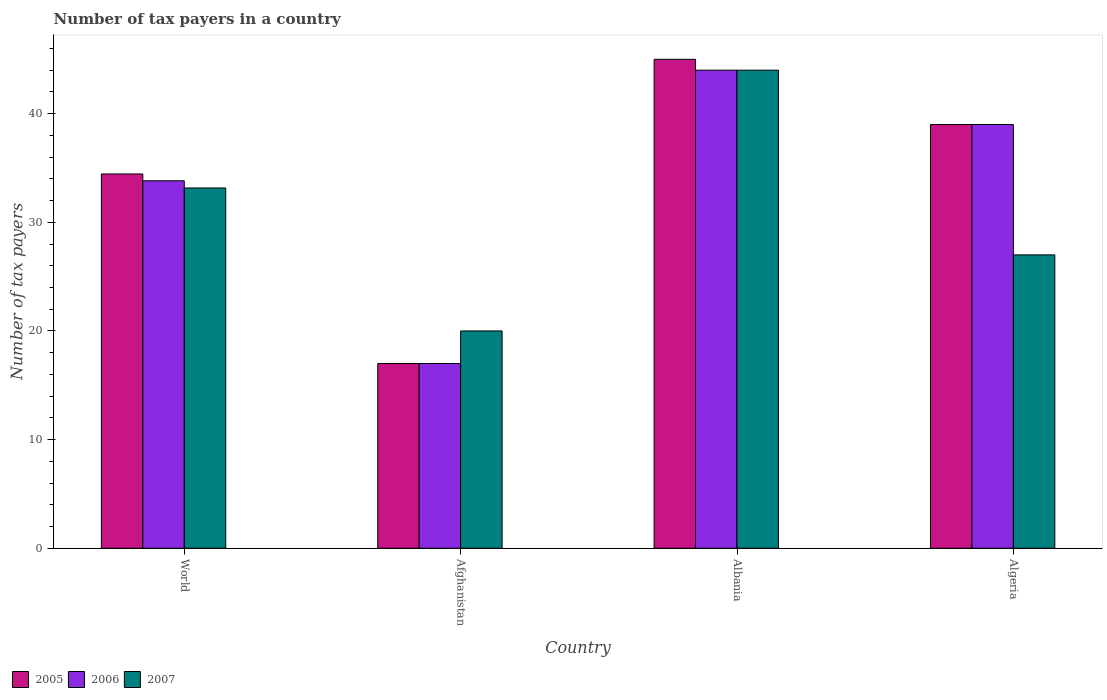How many different coloured bars are there?
Give a very brief answer. 3. Are the number of bars on each tick of the X-axis equal?
Your answer should be very brief. Yes. Across all countries, what is the maximum number of tax payers in in 2007?
Your answer should be very brief. 44. Across all countries, what is the minimum number of tax payers in in 2007?
Ensure brevity in your answer.  20. In which country was the number of tax payers in in 2006 maximum?
Your response must be concise. Albania. In which country was the number of tax payers in in 2005 minimum?
Your answer should be very brief. Afghanistan. What is the total number of tax payers in in 2005 in the graph?
Your response must be concise. 135.45. What is the average number of tax payers in in 2005 per country?
Your answer should be very brief. 33.86. What is the difference between the number of tax payers in of/in 2005 and number of tax payers in of/in 2007 in World?
Keep it short and to the point. 1.29. What is the ratio of the number of tax payers in in 2006 in Albania to that in World?
Your answer should be compact. 1.3. Is the number of tax payers in in 2005 in Algeria less than that in World?
Your answer should be very brief. No. Is the difference between the number of tax payers in in 2005 in Afghanistan and Algeria greater than the difference between the number of tax payers in in 2007 in Afghanistan and Algeria?
Provide a short and direct response. No. What is the difference between the highest and the second highest number of tax payers in in 2006?
Provide a succinct answer. -10.18. What is the difference between the highest and the lowest number of tax payers in in 2005?
Ensure brevity in your answer.  28. Is the sum of the number of tax payers in in 2006 in Afghanistan and Albania greater than the maximum number of tax payers in in 2005 across all countries?
Offer a terse response. Yes. How many bars are there?
Your response must be concise. 12. How many countries are there in the graph?
Keep it short and to the point. 4. Are the values on the major ticks of Y-axis written in scientific E-notation?
Make the answer very short. No. Does the graph contain grids?
Make the answer very short. No. How many legend labels are there?
Provide a short and direct response. 3. What is the title of the graph?
Offer a very short reply. Number of tax payers in a country. What is the label or title of the X-axis?
Your answer should be very brief. Country. What is the label or title of the Y-axis?
Provide a succinct answer. Number of tax payers. What is the Number of tax payers in 2005 in World?
Your answer should be compact. 34.45. What is the Number of tax payers in 2006 in World?
Offer a terse response. 33.82. What is the Number of tax payers of 2007 in World?
Provide a short and direct response. 33.16. What is the Number of tax payers in 2006 in Afghanistan?
Give a very brief answer. 17. What is the Number of tax payers of 2006 in Albania?
Provide a short and direct response. 44. What is the Number of tax payers of 2007 in Albania?
Make the answer very short. 44. What is the Number of tax payers of 2005 in Algeria?
Offer a terse response. 39. What is the Number of tax payers in 2007 in Algeria?
Provide a short and direct response. 27. Across all countries, what is the maximum Number of tax payers in 2005?
Offer a terse response. 45. Across all countries, what is the maximum Number of tax payers in 2007?
Give a very brief answer. 44. Across all countries, what is the minimum Number of tax payers in 2006?
Give a very brief answer. 17. What is the total Number of tax payers in 2005 in the graph?
Offer a terse response. 135.45. What is the total Number of tax payers in 2006 in the graph?
Give a very brief answer. 133.82. What is the total Number of tax payers of 2007 in the graph?
Offer a very short reply. 124.16. What is the difference between the Number of tax payers of 2005 in World and that in Afghanistan?
Offer a very short reply. 17.45. What is the difference between the Number of tax payers of 2006 in World and that in Afghanistan?
Your response must be concise. 16.82. What is the difference between the Number of tax payers of 2007 in World and that in Afghanistan?
Keep it short and to the point. 13.16. What is the difference between the Number of tax payers in 2005 in World and that in Albania?
Give a very brief answer. -10.55. What is the difference between the Number of tax payers of 2006 in World and that in Albania?
Make the answer very short. -10.18. What is the difference between the Number of tax payers of 2007 in World and that in Albania?
Give a very brief answer. -10.84. What is the difference between the Number of tax payers in 2005 in World and that in Algeria?
Your answer should be compact. -4.55. What is the difference between the Number of tax payers of 2006 in World and that in Algeria?
Your response must be concise. -5.18. What is the difference between the Number of tax payers of 2007 in World and that in Algeria?
Give a very brief answer. 6.16. What is the difference between the Number of tax payers in 2005 in Afghanistan and that in Albania?
Your response must be concise. -28. What is the difference between the Number of tax payers in 2005 in Afghanistan and that in Algeria?
Provide a succinct answer. -22. What is the difference between the Number of tax payers in 2007 in Afghanistan and that in Algeria?
Offer a very short reply. -7. What is the difference between the Number of tax payers in 2006 in Albania and that in Algeria?
Provide a succinct answer. 5. What is the difference between the Number of tax payers in 2007 in Albania and that in Algeria?
Make the answer very short. 17. What is the difference between the Number of tax payers in 2005 in World and the Number of tax payers in 2006 in Afghanistan?
Your answer should be compact. 17.45. What is the difference between the Number of tax payers in 2005 in World and the Number of tax payers in 2007 in Afghanistan?
Make the answer very short. 14.45. What is the difference between the Number of tax payers of 2006 in World and the Number of tax payers of 2007 in Afghanistan?
Ensure brevity in your answer.  13.82. What is the difference between the Number of tax payers of 2005 in World and the Number of tax payers of 2006 in Albania?
Offer a very short reply. -9.55. What is the difference between the Number of tax payers in 2005 in World and the Number of tax payers in 2007 in Albania?
Ensure brevity in your answer.  -9.55. What is the difference between the Number of tax payers of 2006 in World and the Number of tax payers of 2007 in Albania?
Ensure brevity in your answer.  -10.18. What is the difference between the Number of tax payers in 2005 in World and the Number of tax payers in 2006 in Algeria?
Provide a succinct answer. -4.55. What is the difference between the Number of tax payers of 2005 in World and the Number of tax payers of 2007 in Algeria?
Provide a succinct answer. 7.45. What is the difference between the Number of tax payers of 2006 in World and the Number of tax payers of 2007 in Algeria?
Ensure brevity in your answer.  6.82. What is the difference between the Number of tax payers in 2005 in Afghanistan and the Number of tax payers in 2007 in Albania?
Ensure brevity in your answer.  -27. What is the difference between the Number of tax payers of 2005 in Afghanistan and the Number of tax payers of 2006 in Algeria?
Offer a very short reply. -22. What is the difference between the Number of tax payers in 2005 in Afghanistan and the Number of tax payers in 2007 in Algeria?
Give a very brief answer. -10. What is the difference between the Number of tax payers of 2006 in Afghanistan and the Number of tax payers of 2007 in Algeria?
Offer a very short reply. -10. What is the difference between the Number of tax payers of 2005 in Albania and the Number of tax payers of 2006 in Algeria?
Offer a very short reply. 6. What is the difference between the Number of tax payers of 2005 in Albania and the Number of tax payers of 2007 in Algeria?
Your response must be concise. 18. What is the average Number of tax payers in 2005 per country?
Keep it short and to the point. 33.86. What is the average Number of tax payers of 2006 per country?
Your answer should be very brief. 33.46. What is the average Number of tax payers of 2007 per country?
Offer a terse response. 31.04. What is the difference between the Number of tax payers in 2005 and Number of tax payers in 2006 in World?
Give a very brief answer. 0.63. What is the difference between the Number of tax payers of 2005 and Number of tax payers of 2007 in World?
Ensure brevity in your answer.  1.29. What is the difference between the Number of tax payers of 2006 and Number of tax payers of 2007 in World?
Give a very brief answer. 0.66. What is the difference between the Number of tax payers in 2006 and Number of tax payers in 2007 in Afghanistan?
Your response must be concise. -3. What is the difference between the Number of tax payers of 2005 and Number of tax payers of 2007 in Albania?
Your answer should be very brief. 1. What is the difference between the Number of tax payers of 2005 and Number of tax payers of 2006 in Algeria?
Offer a very short reply. 0. What is the difference between the Number of tax payers in 2005 and Number of tax payers in 2007 in Algeria?
Keep it short and to the point. 12. What is the ratio of the Number of tax payers in 2005 in World to that in Afghanistan?
Your answer should be compact. 2.03. What is the ratio of the Number of tax payers of 2006 in World to that in Afghanistan?
Offer a very short reply. 1.99. What is the ratio of the Number of tax payers of 2007 in World to that in Afghanistan?
Offer a very short reply. 1.66. What is the ratio of the Number of tax payers in 2005 in World to that in Albania?
Your answer should be compact. 0.77. What is the ratio of the Number of tax payers of 2006 in World to that in Albania?
Your response must be concise. 0.77. What is the ratio of the Number of tax payers in 2007 in World to that in Albania?
Provide a succinct answer. 0.75. What is the ratio of the Number of tax payers in 2005 in World to that in Algeria?
Keep it short and to the point. 0.88. What is the ratio of the Number of tax payers of 2006 in World to that in Algeria?
Your answer should be very brief. 0.87. What is the ratio of the Number of tax payers of 2007 in World to that in Algeria?
Ensure brevity in your answer.  1.23. What is the ratio of the Number of tax payers in 2005 in Afghanistan to that in Albania?
Provide a succinct answer. 0.38. What is the ratio of the Number of tax payers in 2006 in Afghanistan to that in Albania?
Your answer should be compact. 0.39. What is the ratio of the Number of tax payers in 2007 in Afghanistan to that in Albania?
Your answer should be compact. 0.45. What is the ratio of the Number of tax payers of 2005 in Afghanistan to that in Algeria?
Give a very brief answer. 0.44. What is the ratio of the Number of tax payers of 2006 in Afghanistan to that in Algeria?
Your answer should be compact. 0.44. What is the ratio of the Number of tax payers of 2007 in Afghanistan to that in Algeria?
Your response must be concise. 0.74. What is the ratio of the Number of tax payers of 2005 in Albania to that in Algeria?
Keep it short and to the point. 1.15. What is the ratio of the Number of tax payers of 2006 in Albania to that in Algeria?
Offer a terse response. 1.13. What is the ratio of the Number of tax payers in 2007 in Albania to that in Algeria?
Offer a very short reply. 1.63. What is the difference between the highest and the second highest Number of tax payers in 2006?
Offer a very short reply. 5. What is the difference between the highest and the second highest Number of tax payers in 2007?
Your answer should be compact. 10.84. What is the difference between the highest and the lowest Number of tax payers in 2005?
Provide a succinct answer. 28. What is the difference between the highest and the lowest Number of tax payers of 2006?
Your answer should be very brief. 27. 